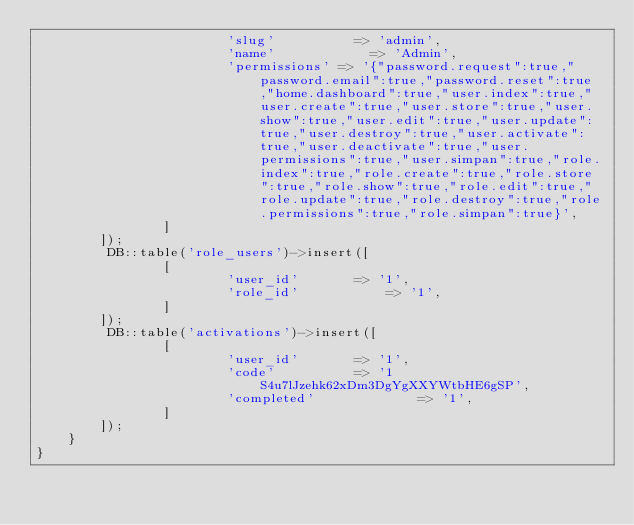Convert code to text. <code><loc_0><loc_0><loc_500><loc_500><_PHP_>			    		'slug' 		    => 'admin',
			    		'name' 			  => 'Admin',
			    		'permissions' => '{"password.request":true,"password.email":true,"password.reset":true,"home.dashboard":true,"user.index":true,"user.create":true,"user.store":true,"user.show":true,"user.edit":true,"user.update":true,"user.destroy":true,"user.activate":true,"user.deactivate":true,"user.permissions":true,"user.simpan":true,"role.index":true,"role.create":true,"role.store":true,"role.show":true,"role.edit":true,"role.update":true,"role.destroy":true,"role.permissions":true,"role.simpan":true}',
			    ]
        ]);
		 DB::table('role_users')->insert([
			    [
			    		'user_id' 		=> '1',
			    		'role_id' 			=> '1',
			    ]
        ]);
		 DB::table('activations')->insert([
			    [
			    		'user_id' 		=> '1',
			    		'code' 			=> '1S4u7lJzehk62xDm3DgYgXXYWtbHE6gSP',
			    		'completed' 			=> '1',
			    ]
        ]);
    }
}
</code> 